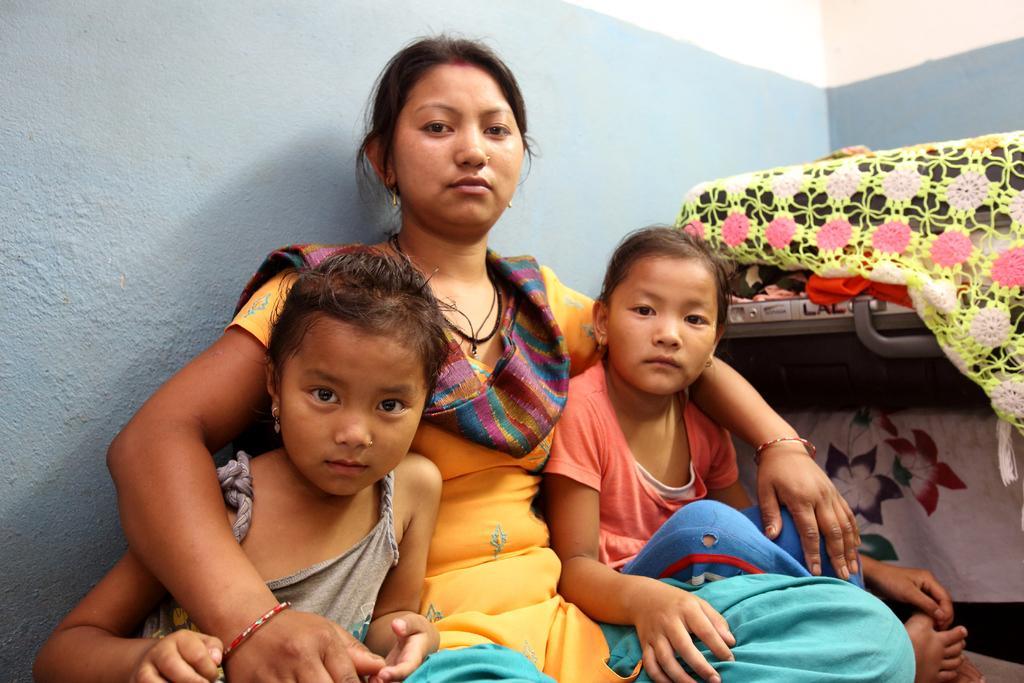Could you give a brief overview of what you see in this image? In this picture there is a lady and two children in the center of the image and there are suitcases on the right side of the image. 